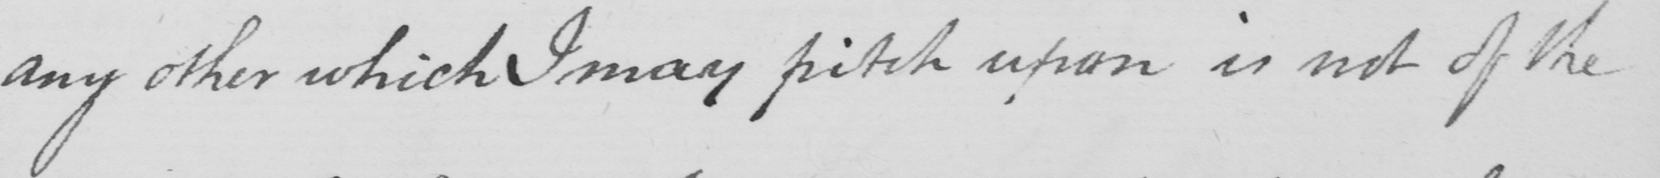What is written in this line of handwriting? any other which I may pitch upon is not of the 